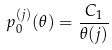<formula> <loc_0><loc_0><loc_500><loc_500>p _ { 0 } ^ { ( j ) } ( \theta ) = \frac { C _ { 1 } } { \theta ( j ) }</formula> 